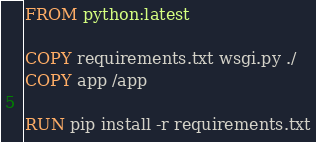Convert code to text. <code><loc_0><loc_0><loc_500><loc_500><_Dockerfile_>FROM python:latest

COPY requirements.txt wsgi.py ./
COPY app /app

RUN pip install -r requirements.txt

</code> 